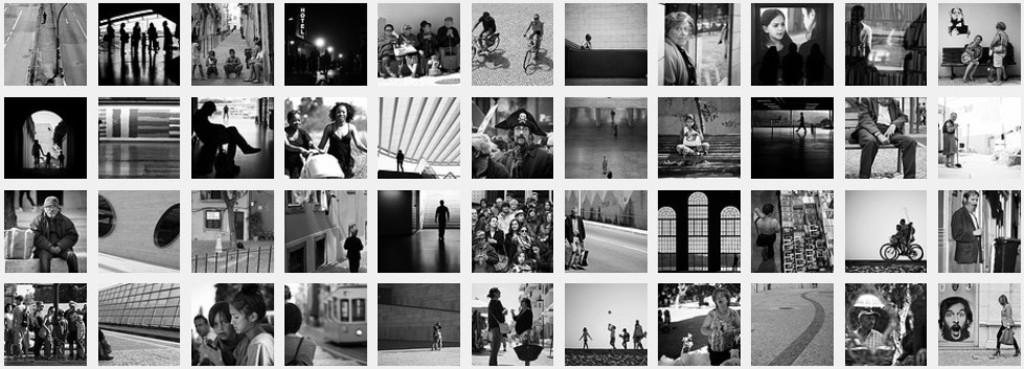What is the main subject of the image? The main subject of the image is a collage of different images. Can you describe the content of the collage? The collage contains images of a group of people. What type of order do the snails follow in the collage? There are no snails present in the collage, so there is no order for them to follow. Who is the partner of the person in the collage? The collage contains images of a group of people, but it does not specify any partners or relationships between them. 